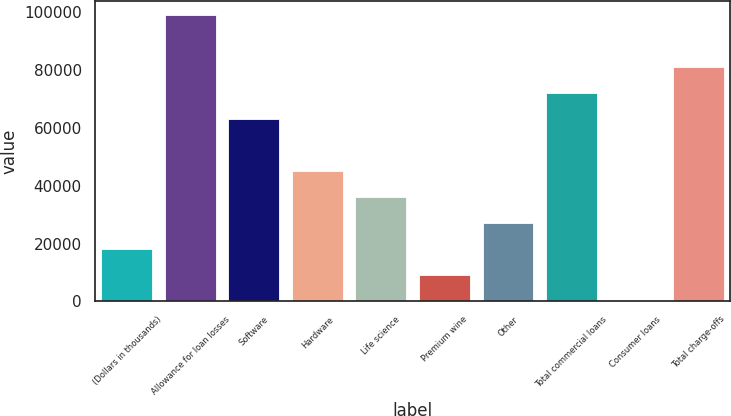Convert chart to OTSL. <chart><loc_0><loc_0><loc_500><loc_500><bar_chart><fcel>(Dollars in thousands)<fcel>Allowance for loan losses<fcel>Software<fcel>Hardware<fcel>Life science<fcel>Premium wine<fcel>Other<fcel>Total commercial loans<fcel>Consumer loans<fcel>Total charge-offs<nl><fcel>18165.4<fcel>98919.7<fcel>63028.9<fcel>45083.5<fcel>36110.8<fcel>9192.7<fcel>27138.1<fcel>72001.6<fcel>220<fcel>80974.3<nl></chart> 